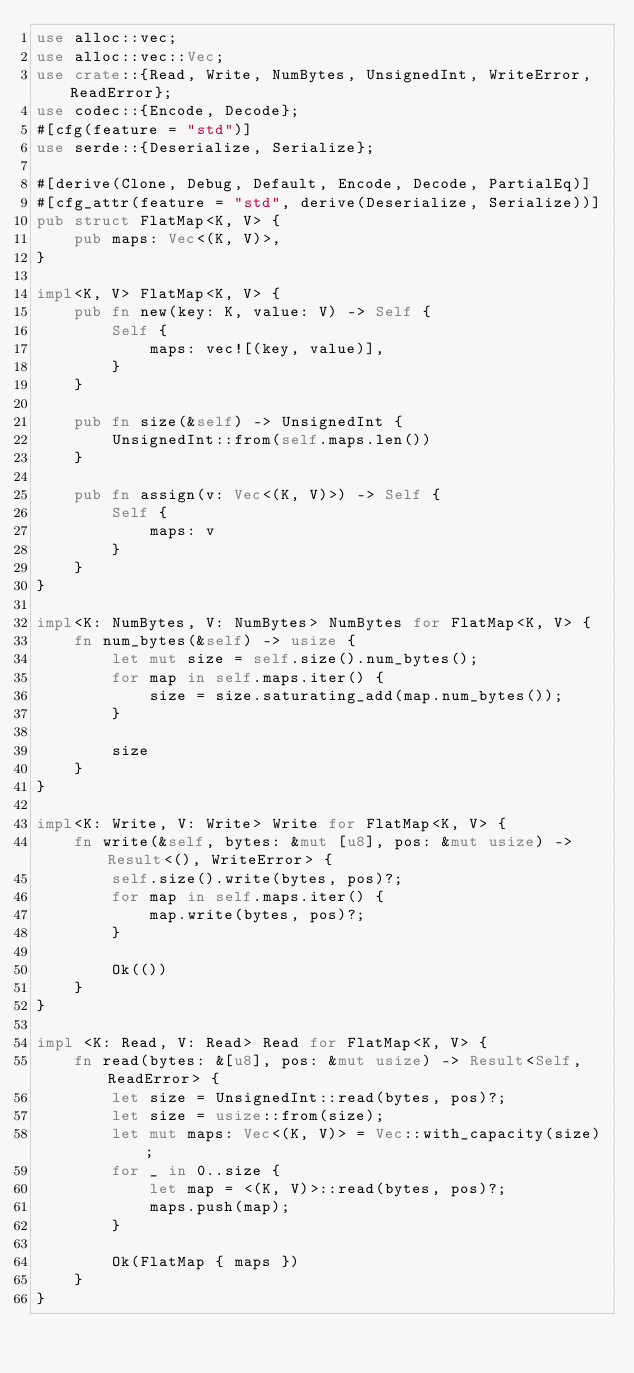<code> <loc_0><loc_0><loc_500><loc_500><_Rust_>use alloc::vec;
use alloc::vec::Vec;
use crate::{Read, Write, NumBytes, UnsignedInt, WriteError, ReadError};
use codec::{Encode, Decode};
#[cfg(feature = "std")]
use serde::{Deserialize, Serialize};

#[derive(Clone, Debug, Default, Encode, Decode, PartialEq)]
#[cfg_attr(feature = "std", derive(Deserialize, Serialize))]
pub struct FlatMap<K, V> {
    pub maps: Vec<(K, V)>,
}

impl<K, V> FlatMap<K, V> {
    pub fn new(key: K, value: V) -> Self {
        Self {
            maps: vec![(key, value)],
        }
    }

    pub fn size(&self) -> UnsignedInt {
        UnsignedInt::from(self.maps.len())
    }

    pub fn assign(v: Vec<(K, V)>) -> Self {
        Self {
            maps: v
        }
    }
}

impl<K: NumBytes, V: NumBytes> NumBytes for FlatMap<K, V> {
    fn num_bytes(&self) -> usize {
        let mut size = self.size().num_bytes();
        for map in self.maps.iter() {
            size = size.saturating_add(map.num_bytes());
        }

        size
    }
}

impl<K: Write, V: Write> Write for FlatMap<K, V> {
    fn write(&self, bytes: &mut [u8], pos: &mut usize) -> Result<(), WriteError> {
        self.size().write(bytes, pos)?;
        for map in self.maps.iter() {
            map.write(bytes, pos)?;
        }

        Ok(())
    }
}

impl <K: Read, V: Read> Read for FlatMap<K, V> {
    fn read(bytes: &[u8], pos: &mut usize) -> Result<Self, ReadError> {
        let size = UnsignedInt::read(bytes, pos)?;
        let size = usize::from(size);
        let mut maps: Vec<(K, V)> = Vec::with_capacity(size);
        for _ in 0..size {
            let map = <(K, V)>::read(bytes, pos)?;
            maps.push(map);
        }

        Ok(FlatMap { maps })
    }
}
</code> 